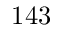Convert formula to latex. <formula><loc_0><loc_0><loc_500><loc_500>1 4 3</formula> 